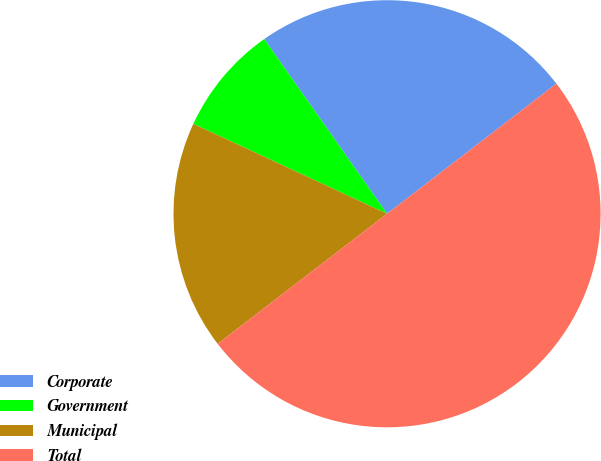Convert chart to OTSL. <chart><loc_0><loc_0><loc_500><loc_500><pie_chart><fcel>Corporate<fcel>Government<fcel>Municipal<fcel>Total<nl><fcel>24.33%<fcel>8.33%<fcel>17.34%<fcel>50.0%<nl></chart> 